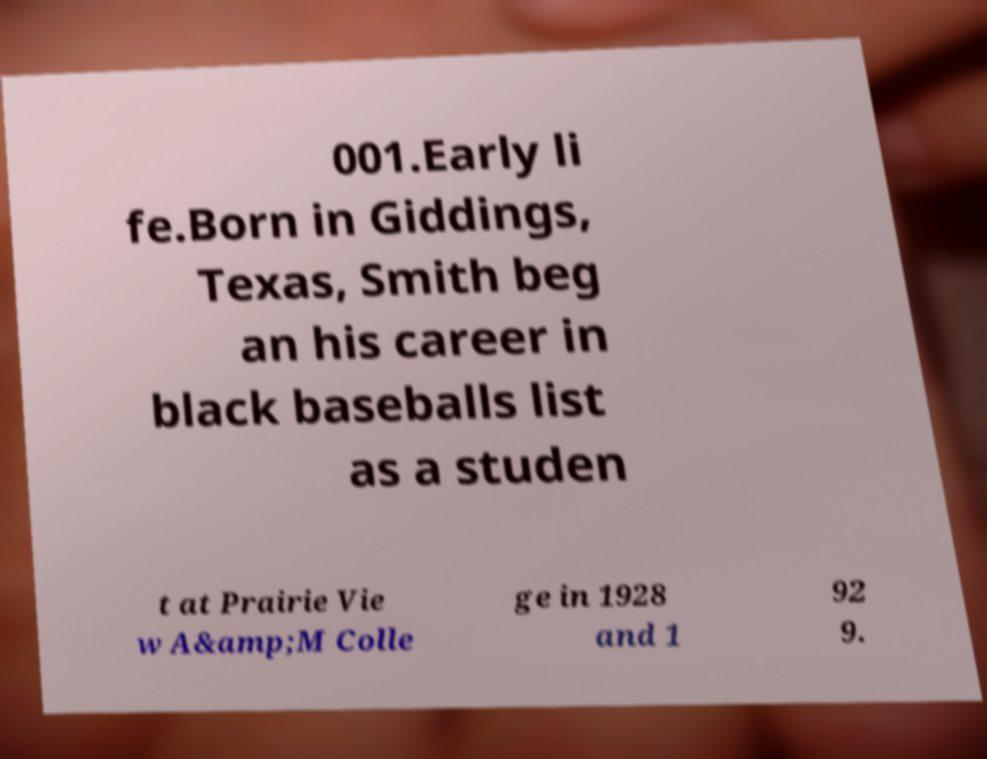Can you read and provide the text displayed in the image?This photo seems to have some interesting text. Can you extract and type it out for me? 001.Early li fe.Born in Giddings, Texas, Smith beg an his career in black baseballs list as a studen t at Prairie Vie w A&amp;M Colle ge in 1928 and 1 92 9. 